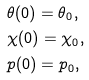Convert formula to latex. <formula><loc_0><loc_0><loc_500><loc_500>& \theta ( 0 ) = \theta _ { 0 } , \\ & \chi ( 0 ) = \chi _ { 0 } , \\ & p ( 0 ) = p _ { 0 } ,</formula> 